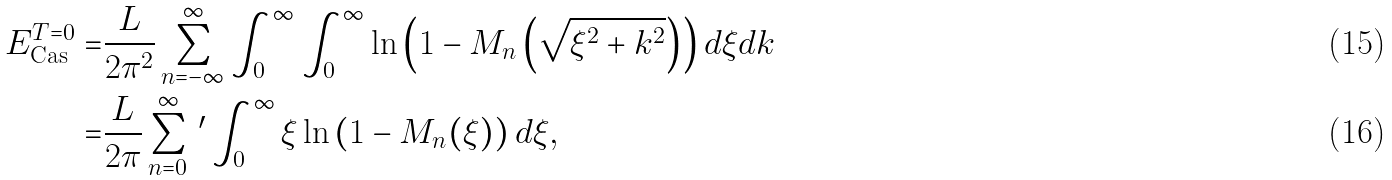<formula> <loc_0><loc_0><loc_500><loc_500>E _ { \text {Cas} } ^ { T = 0 } = & \frac { L } { 2 \pi ^ { 2 } } \sum _ { n = - \infty } ^ { \infty } \int _ { 0 } ^ { \infty } \int _ { 0 } ^ { \infty } \ln \left ( 1 - M _ { n } \left ( \sqrt { \xi ^ { 2 } + k ^ { 2 } } \right ) \right ) d \xi d k \\ = & \frac { L } { 2 \pi } \sum _ { n = 0 } ^ { \infty } \, ^ { \prime } \int _ { 0 } ^ { \infty } \xi \ln \left ( 1 - M _ { n } ( \xi ) \right ) d \xi ,</formula> 